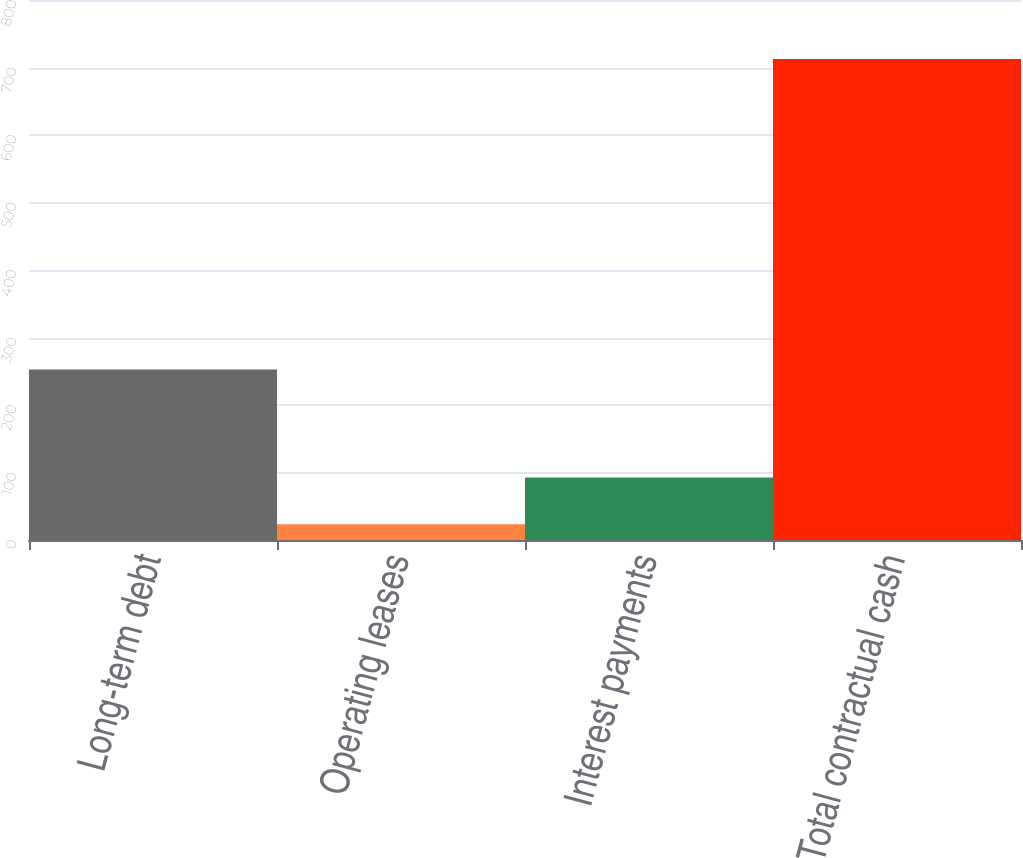<chart> <loc_0><loc_0><loc_500><loc_500><bar_chart><fcel>Long-term debt<fcel>Operating leases<fcel>Interest payments<fcel>Total contractual cash<nl><fcel>252.6<fcel>23.5<fcel>92.41<fcel>712.6<nl></chart> 